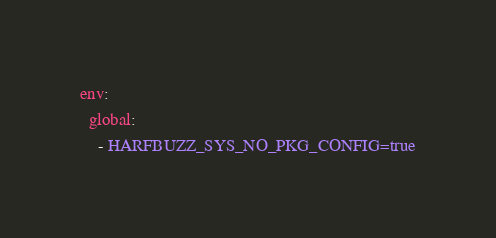Convert code to text. <code><loc_0><loc_0><loc_500><loc_500><_YAML_>env:
  global:
    - HARFBUZZ_SYS_NO_PKG_CONFIG=true
</code> 